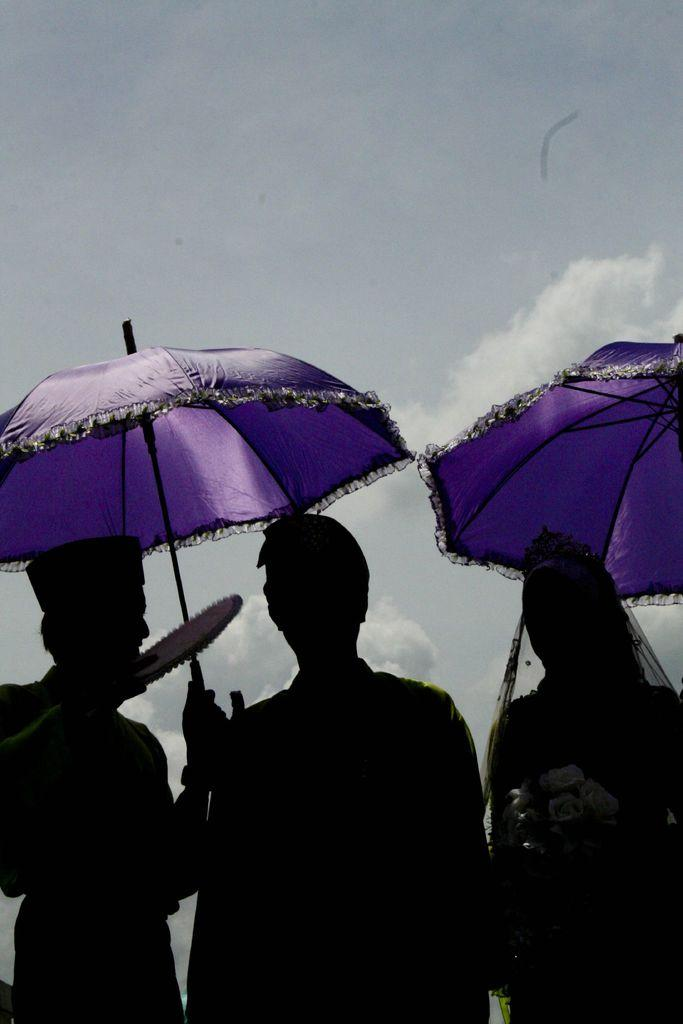How many people are in the image? There are three persons in the image. What is one of the persons holding? One of the persons is holding an umbrella and an object. Are there any other umbrellas visible in the image? Yes, there is another umbrella in the image. What can be seen in the sky in the image? There are clouds in the sky. What type of loaf is being carried by the achiever in the image? There is no achiever or loaf present in the image. What type of police vehicle can be seen in the image? There is no police vehicle present in the image. 